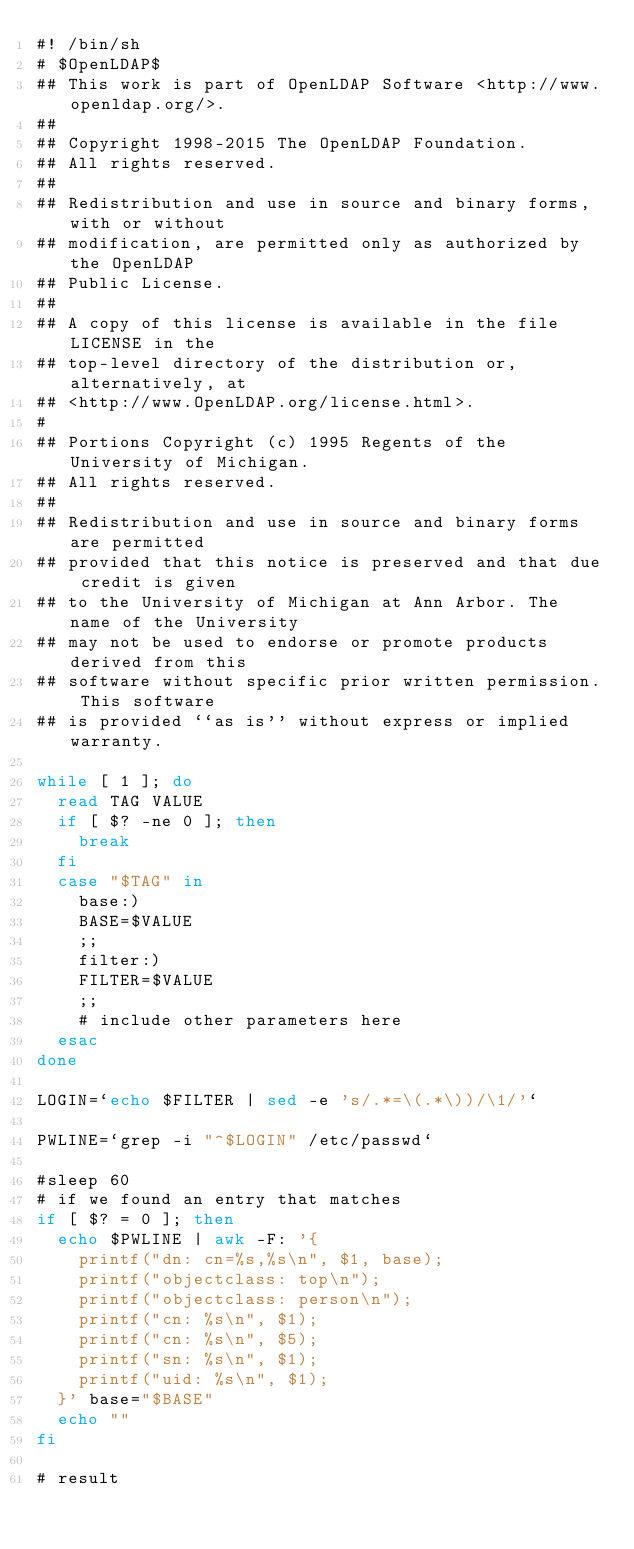Convert code to text. <code><loc_0><loc_0><loc_500><loc_500><_Bash_>#! /bin/sh
# $OpenLDAP$
## This work is part of OpenLDAP Software <http://www.openldap.org/>.
##
## Copyright 1998-2015 The OpenLDAP Foundation.
## All rights reserved.
##
## Redistribution and use in source and binary forms, with or without
## modification, are permitted only as authorized by the OpenLDAP
## Public License.
##
## A copy of this license is available in the file LICENSE in the
## top-level directory of the distribution or, alternatively, at
## <http://www.OpenLDAP.org/license.html>.
#
## Portions Copyright (c) 1995 Regents of the University of Michigan.
## All rights reserved.
##
## Redistribution and use in source and binary forms are permitted
## provided that this notice is preserved and that due credit is given
## to the University of Michigan at Ann Arbor. The name of the University
## may not be used to endorse or promote products derived from this
## software without specific prior written permission. This software
## is provided ``as is'' without express or implied warranty.

while [ 1 ]; do
	read TAG VALUE
	if [ $? -ne 0 ]; then
		break
	fi
	case "$TAG" in
		base:)
		BASE=$VALUE
		;;
		filter:)
		FILTER=$VALUE
		;;
		# include other parameters here
	esac
done

LOGIN=`echo $FILTER | sed -e 's/.*=\(.*\))/\1/'`

PWLINE=`grep -i "^$LOGIN" /etc/passwd`

#sleep 60
# if we found an entry that matches
if [ $? = 0 ]; then
	echo $PWLINE | awk -F: '{
		printf("dn: cn=%s,%s\n", $1, base);
		printf("objectclass: top\n");
		printf("objectclass: person\n");
		printf("cn: %s\n", $1);
		printf("cn: %s\n", $5);
		printf("sn: %s\n", $1);
		printf("uid: %s\n", $1);
	}' base="$BASE"
	echo ""
fi

# result</code> 